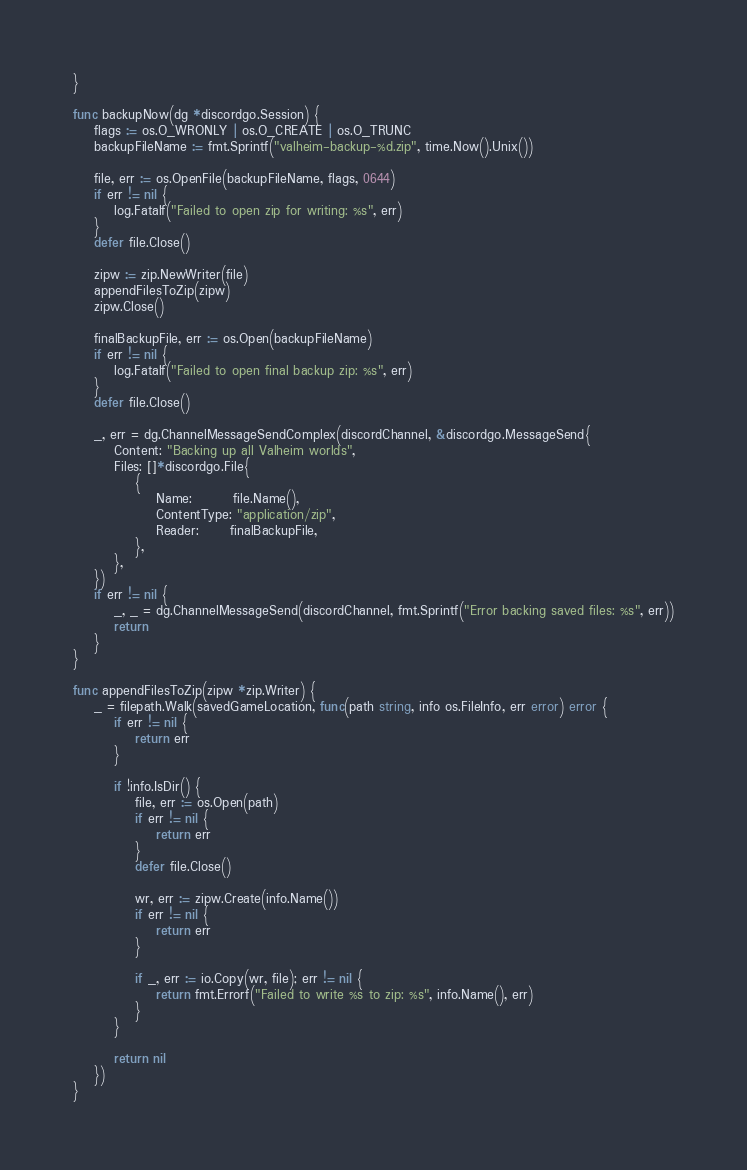Convert code to text. <code><loc_0><loc_0><loc_500><loc_500><_Go_>}

func backupNow(dg *discordgo.Session) {
	flags := os.O_WRONLY | os.O_CREATE | os.O_TRUNC
	backupFileName := fmt.Sprintf("valheim-backup-%d.zip", time.Now().Unix())

	file, err := os.OpenFile(backupFileName, flags, 0644)
	if err != nil {
		log.Fatalf("Failed to open zip for writing: %s", err)
	}
	defer file.Close()

	zipw := zip.NewWriter(file)
	appendFilesToZip(zipw)
	zipw.Close()

	finalBackupFile, err := os.Open(backupFileName)
	if err != nil {
		log.Fatalf("Failed to open final backup zip: %s", err)
	}
	defer file.Close()

	_, err = dg.ChannelMessageSendComplex(discordChannel, &discordgo.MessageSend{
		Content: "Backing up all Valheim worlds",
		Files: []*discordgo.File{
			{
				Name:        file.Name(),
				ContentType: "application/zip",
				Reader:      finalBackupFile,
			},
		},
	})
	if err != nil {
		_, _ = dg.ChannelMessageSend(discordChannel, fmt.Sprintf("Error backing saved files: %s", err))
		return
	}
}

func appendFilesToZip(zipw *zip.Writer) {
	_ = filepath.Walk(savedGameLocation, func(path string, info os.FileInfo, err error) error {
		if err != nil {
			return err
		}

		if !info.IsDir() {
			file, err := os.Open(path)
			if err != nil {
				return err
			}
			defer file.Close()

			wr, err := zipw.Create(info.Name())
			if err != nil {
				return err
			}

			if _, err := io.Copy(wr, file); err != nil {
				return fmt.Errorf("Failed to write %s to zip: %s", info.Name(), err)
			}
		}

		return nil
	})
}
</code> 